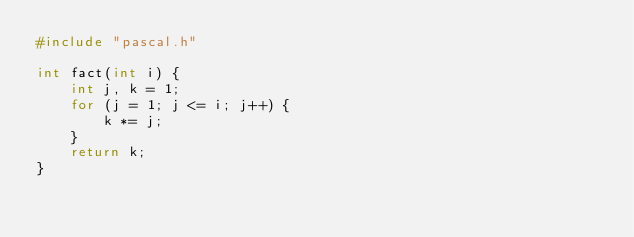<code> <loc_0><loc_0><loc_500><loc_500><_C_>#include "pascal.h"

int fact(int i) {
	int j, k = 1;
	for (j = 1; j <= i; j++) {
		k *= j;
	}
	return k;
}
</code> 